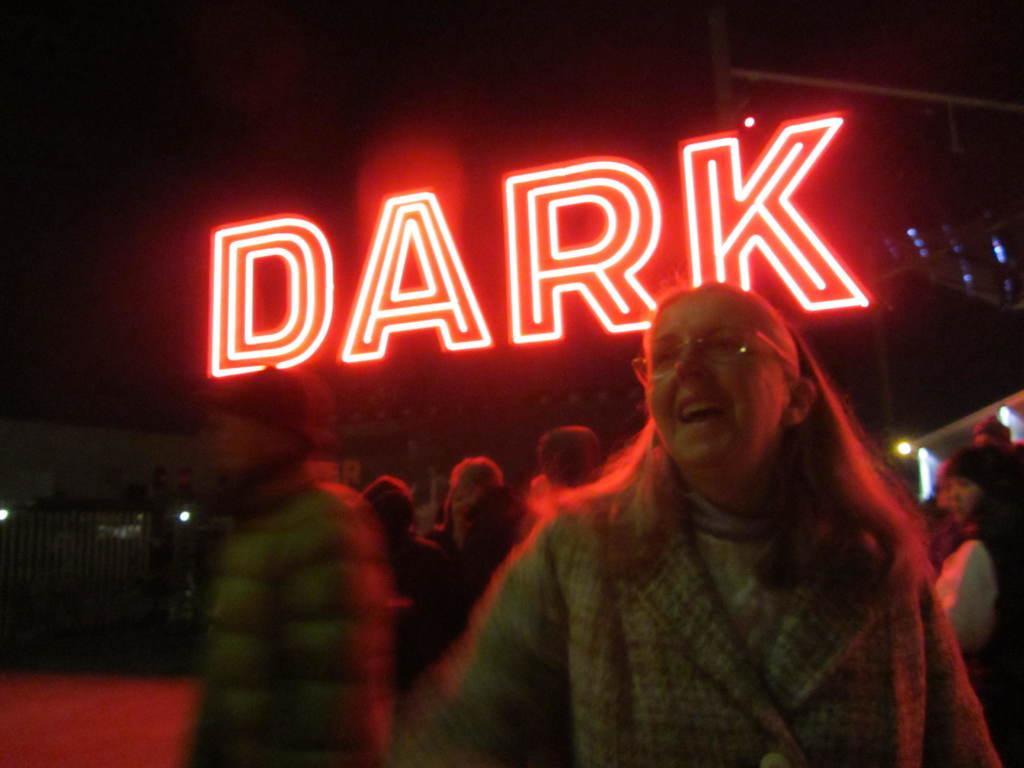Please provide a concise description of this image. In the foreground of this picture we can see the group of persons. In the background we can see the lights and the text and some other objects. 